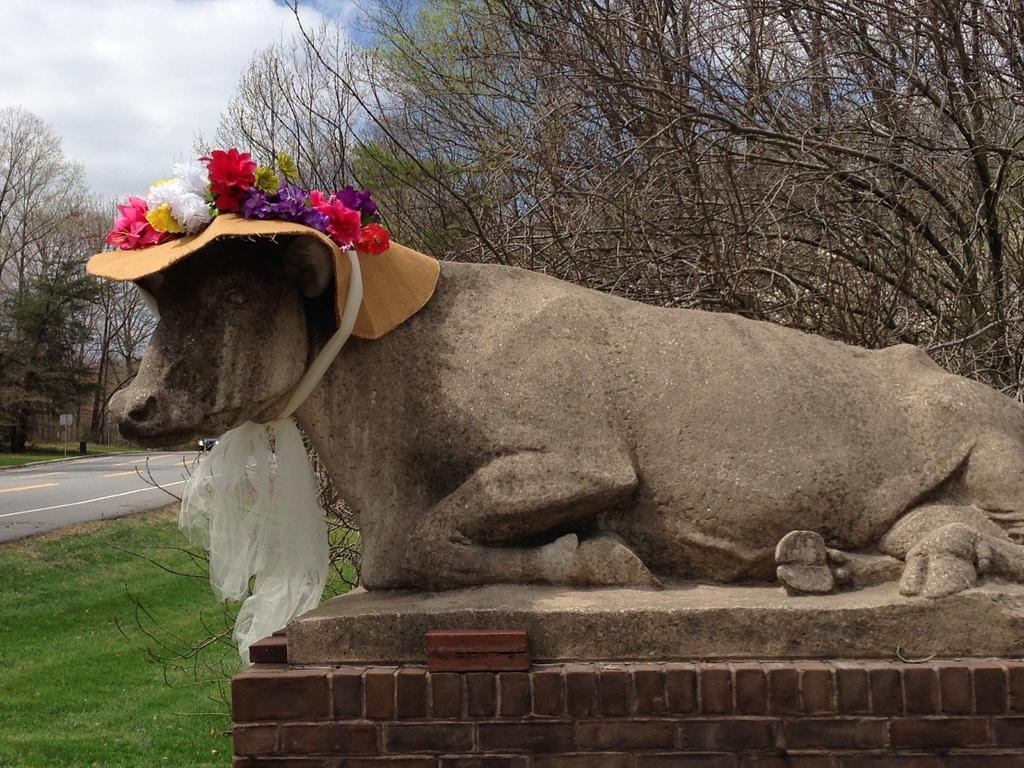What is the main subject of the image? There is a statue in the image. What decorations are on the statue? The statue has a ribbon and flowers on it. What can be seen in the background of the image? There are trees, a cloudy sky, a road, a board, and grass in the background of the image. What type of cub is playing with the sheet in the image? There is no cub or sheet present in the image. 